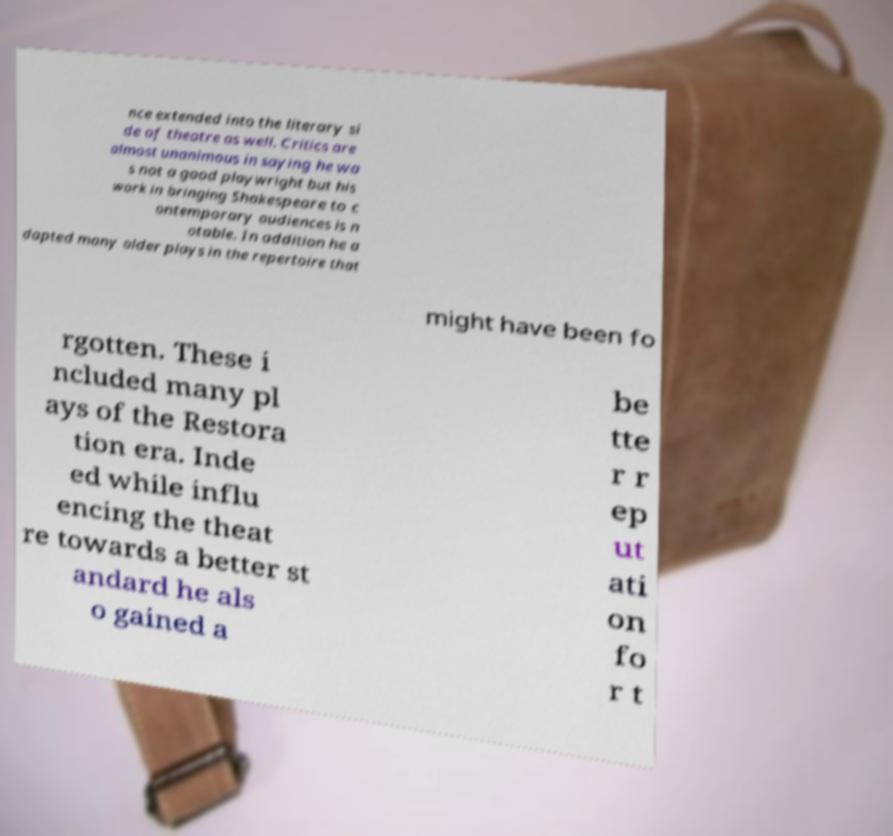I need the written content from this picture converted into text. Can you do that? nce extended into the literary si de of theatre as well. Critics are almost unanimous in saying he wa s not a good playwright but his work in bringing Shakespeare to c ontemporary audiences is n otable. In addition he a dapted many older plays in the repertoire that might have been fo rgotten. These i ncluded many pl ays of the Restora tion era. Inde ed while influ encing the theat re towards a better st andard he als o gained a be tte r r ep ut ati on fo r t 